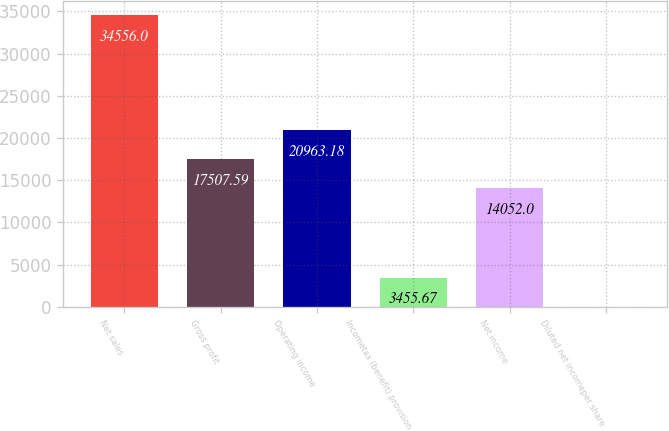<chart> <loc_0><loc_0><loc_500><loc_500><bar_chart><fcel>Net sales<fcel>Gross profit<fcel>Operating income<fcel>Incometax (benefit) provision<fcel>Net income<fcel>Diluted net incomeper share<nl><fcel>34556<fcel>17507.6<fcel>20963.2<fcel>3455.67<fcel>14052<fcel>0.08<nl></chart> 